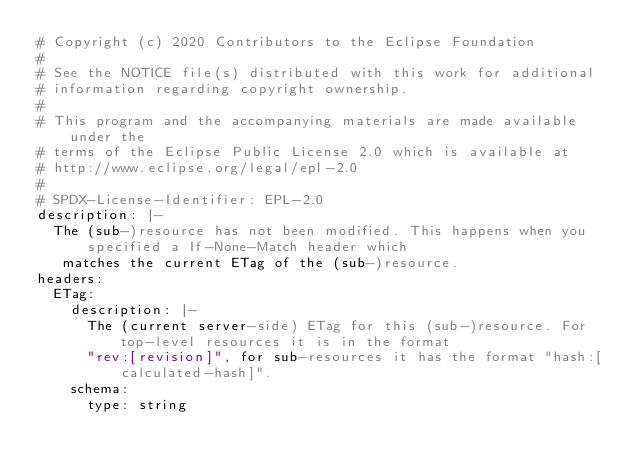Convert code to text. <code><loc_0><loc_0><loc_500><loc_500><_YAML_># Copyright (c) 2020 Contributors to the Eclipse Foundation
#
# See the NOTICE file(s) distributed with this work for additional
# information regarding copyright ownership.
#
# This program and the accompanying materials are made available under the
# terms of the Eclipse Public License 2.0 which is available at
# http://www.eclipse.org/legal/epl-2.0
#
# SPDX-License-Identifier: EPL-2.0
description: |-
  The (sub-)resource has not been modified. This happens when you specified a If-None-Match header which
   matches the current ETag of the (sub-)resource.
headers:
  ETag:
    description: |-
      The (current server-side) ETag for this (sub-)resource. For top-level resources it is in the format
      "rev:[revision]", for sub-resources it has the format "hash:[calculated-hash]".
    schema:
      type: string</code> 